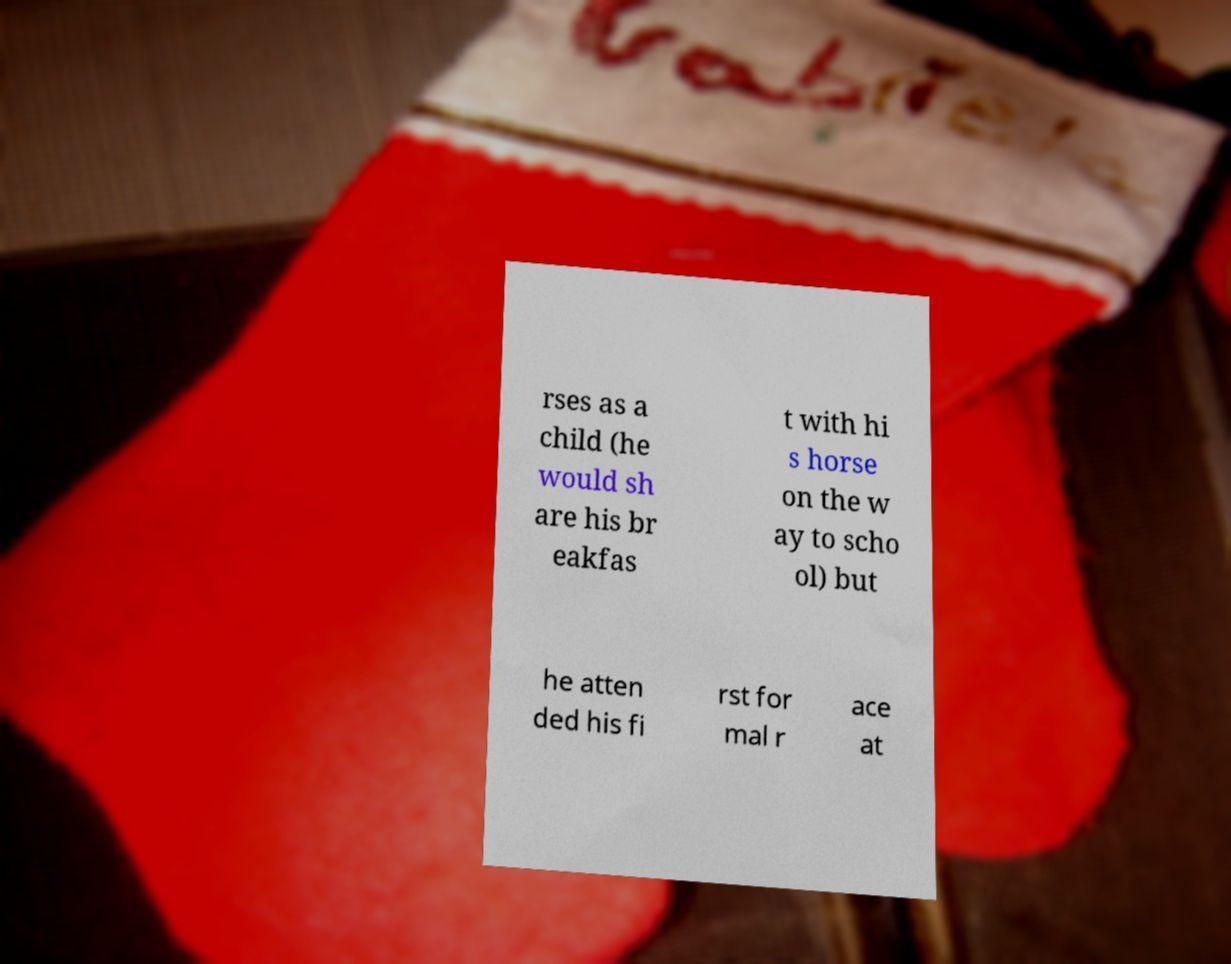Can you accurately transcribe the text from the provided image for me? rses as a child (he would sh are his br eakfas t with hi s horse on the w ay to scho ol) but he atten ded his fi rst for mal r ace at 